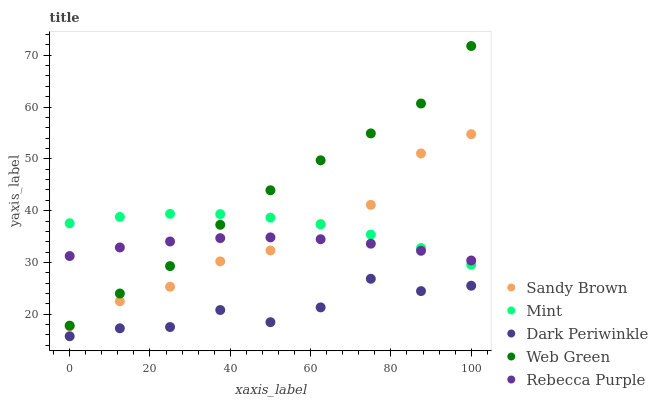Does Dark Periwinkle have the minimum area under the curve?
Answer yes or no. Yes. Does Web Green have the maximum area under the curve?
Answer yes or no. Yes. Does Sandy Brown have the minimum area under the curve?
Answer yes or no. No. Does Sandy Brown have the maximum area under the curve?
Answer yes or no. No. Is Rebecca Purple the smoothest?
Answer yes or no. Yes. Is Dark Periwinkle the roughest?
Answer yes or no. Yes. Is Sandy Brown the smoothest?
Answer yes or no. No. Is Sandy Brown the roughest?
Answer yes or no. No. Does Dark Periwinkle have the lowest value?
Answer yes or no. Yes. Does Sandy Brown have the lowest value?
Answer yes or no. No. Does Web Green have the highest value?
Answer yes or no. Yes. Does Sandy Brown have the highest value?
Answer yes or no. No. Is Dark Periwinkle less than Rebecca Purple?
Answer yes or no. Yes. Is Mint greater than Dark Periwinkle?
Answer yes or no. Yes. Does Rebecca Purple intersect Sandy Brown?
Answer yes or no. Yes. Is Rebecca Purple less than Sandy Brown?
Answer yes or no. No. Is Rebecca Purple greater than Sandy Brown?
Answer yes or no. No. Does Dark Periwinkle intersect Rebecca Purple?
Answer yes or no. No. 